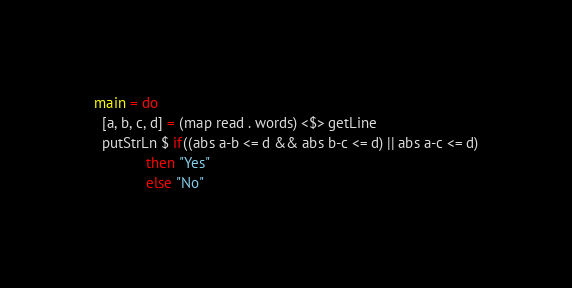<code> <loc_0><loc_0><loc_500><loc_500><_Haskell_>main = do
  [a, b, c, d] = (map read . words) <$> getLine
  putStrLn $ if((abs a-b <= d && abs b-c <= d) || abs a-c <= d)
             then "Yes"
             else "No"</code> 